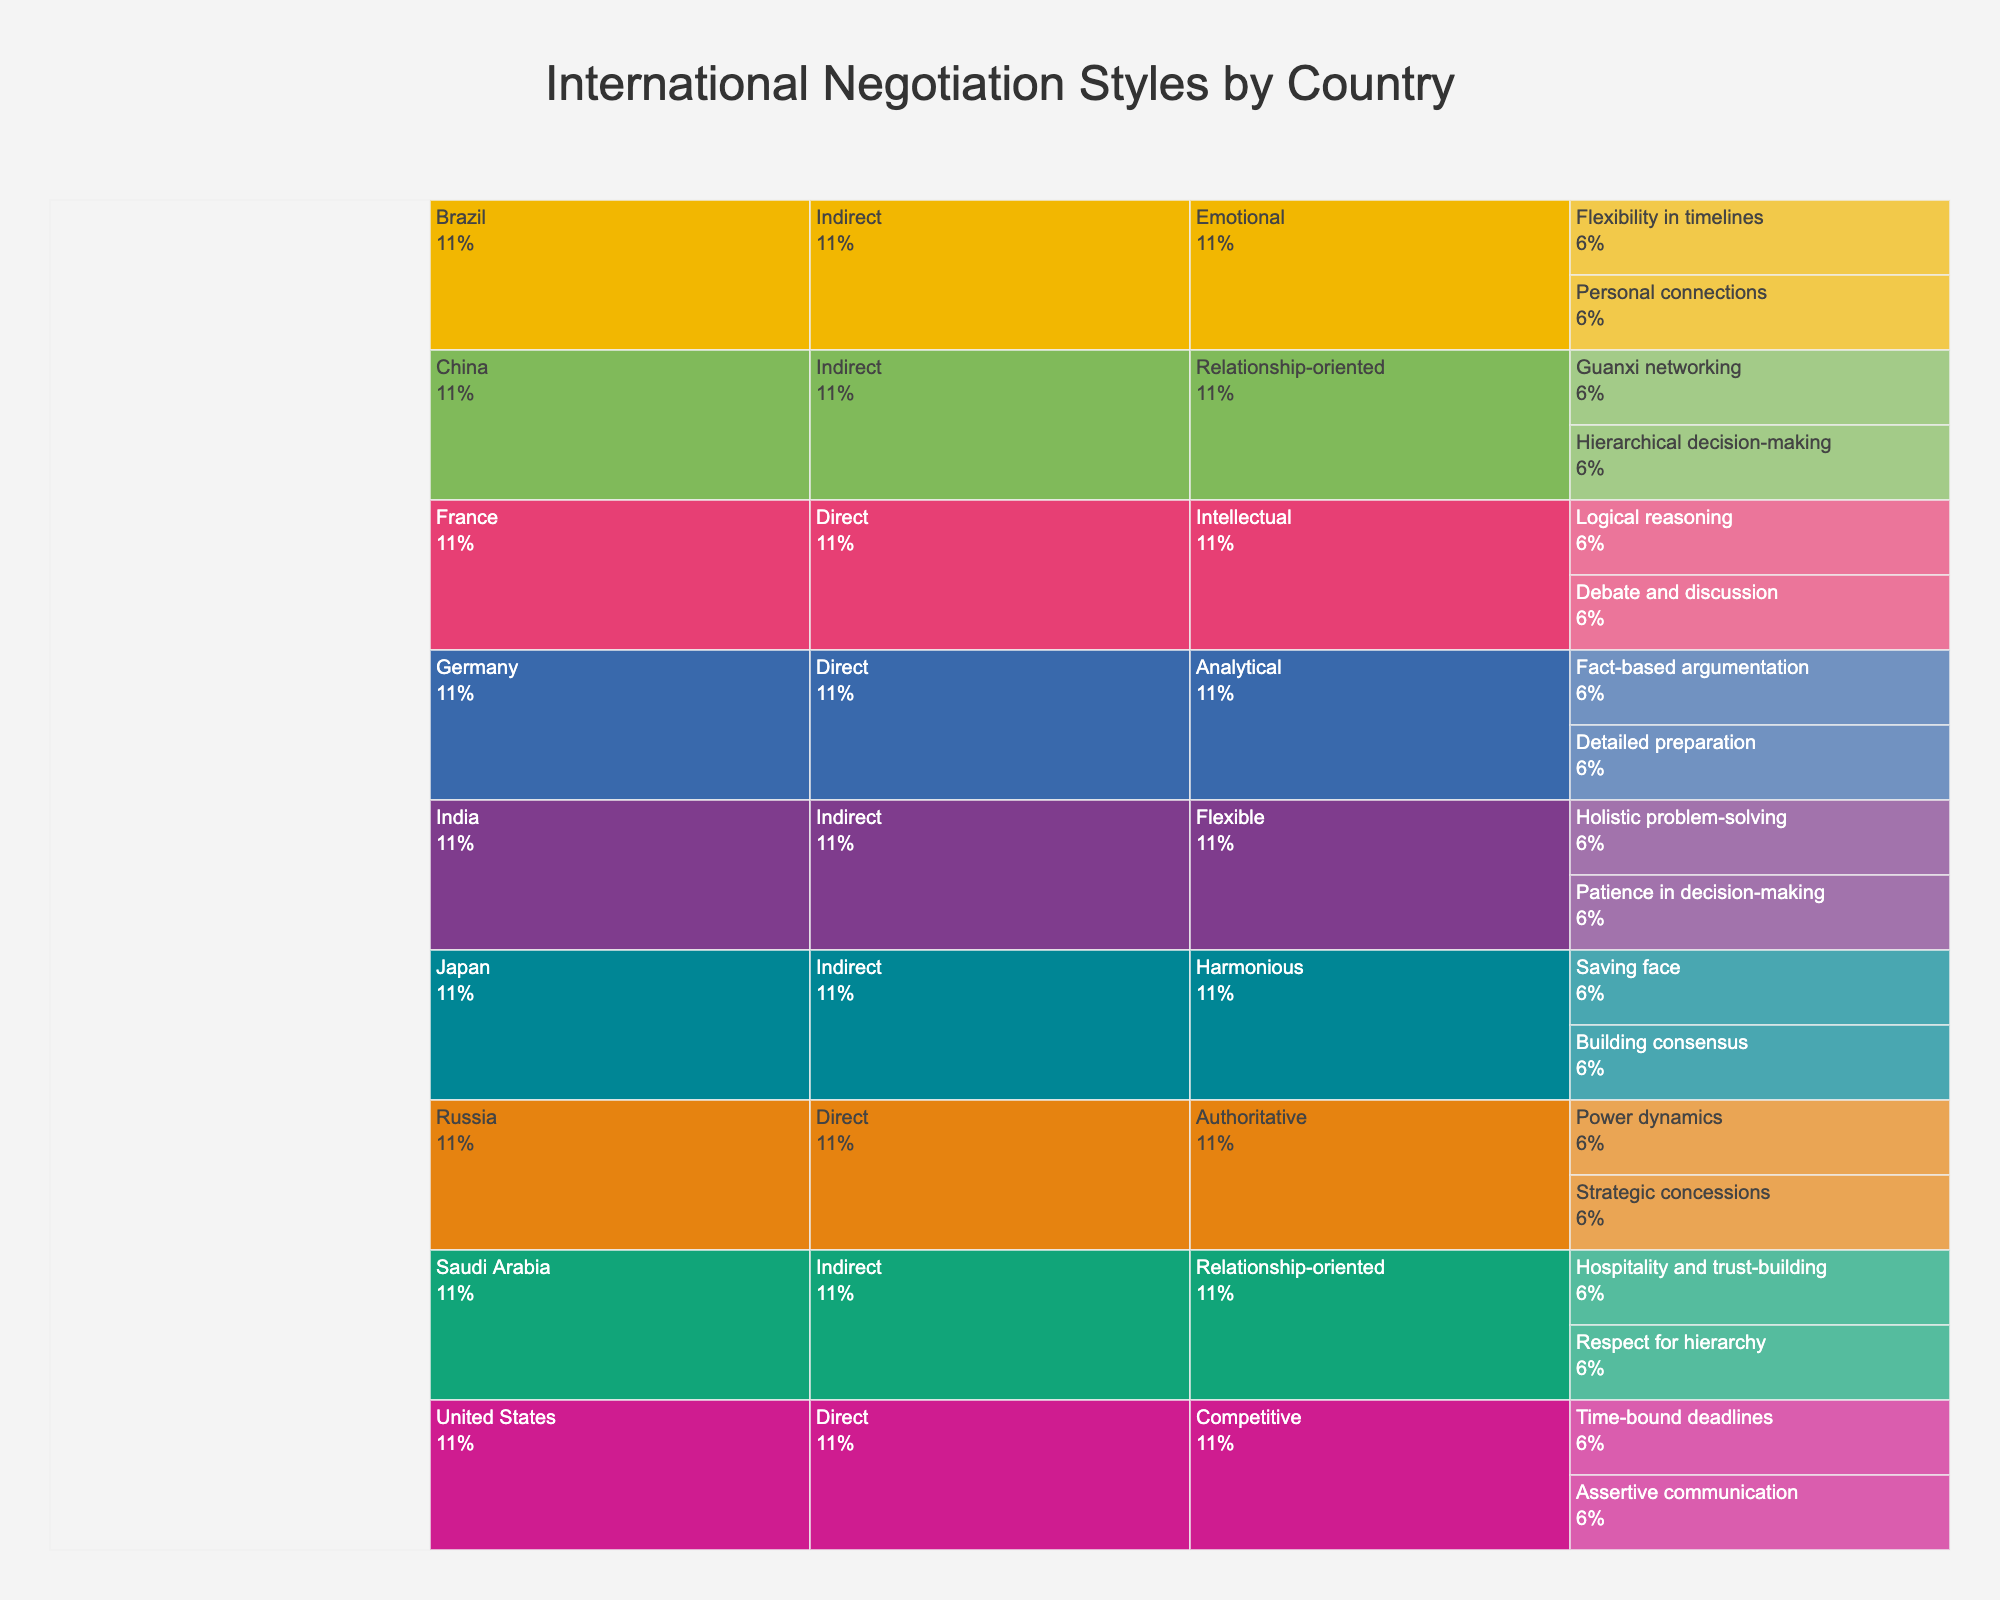What is the title of this figure? The title is displayed at the top of the figure in large, readable font. You can find it centered above the chart.
Answer: International Negotiation Styles by Country Which country employs "Guanxi networking" in their negotiation style? Look at the hierarchical structure of the icicle chart. Identify the country connected to "Indirect" negotiation style and "Relationship-oriented" approach, then find the specific technique "Guanxi networking".
Answer: China How does the negotiation style of Japan differ from that of the United States? Identify the negotiation styles of both countries in the chart. Japan uses an "Indirect" negotiation style with "Harmonious" approaches, while the United States uses a "Direct" style with "Competitive" approaches.
Answer: Japan: Indirect, Harmonious; United States: Direct, Competitive How many countries utilize a "Direct" negotiation style? Review the branches of the icicle chart to count the number of unique countries listed under the "Direct" negotiation style category.
Answer: 4 What are the specific techniques used in Germany's "Analytical" approach? Follow the hierarchy for Germany and its "Direct" negotiation style. Under "Analytical", identify the techniques listed.
Answer: Detailed preparation, Fact-based argumentation Which country focuses on "Personal connections" as part of their negotiation style, and what type of approach do they use? Trace the hierarchy to find the country associated with "Personal connections". Note the approach preceding the specific technique.
Answer: Brazil, Emotional Compare the negotiation styles of Brazil and India. First, locate Brazil and India in the hierarchy and note their negotiation styles. Brazil uses an "Indirect, Emotional" style, while India uses an "Indirect, Flexible" style.
Answer: Brazil: Indirect, Emotional; India: Indirect, Flexible Which country has techniques involving "Patience in decision-making" and "Holistic problem-solving"? Locate the country with these specific techniques by following the hierarchy associated with "Patience in decision-making" and "Holistic problem-solving".
Answer: India What common approaches are used by China and Saudi Arabia in their negotiation styles? Locate China and Saudi Arabia in the chart and identify the approaches under their negotiation styles. Note any approaches that appear for both countries.
Answer: Relationship-oriented What percentage of techniques are associated with the United States in the chart? Find the percentage displayed in the text of the icicle chart for the United States' section. This will give you the proportion of techniques attributed to the U.S.
Answer: (Determine the specific percentage shown on the chart for the U.S.) 